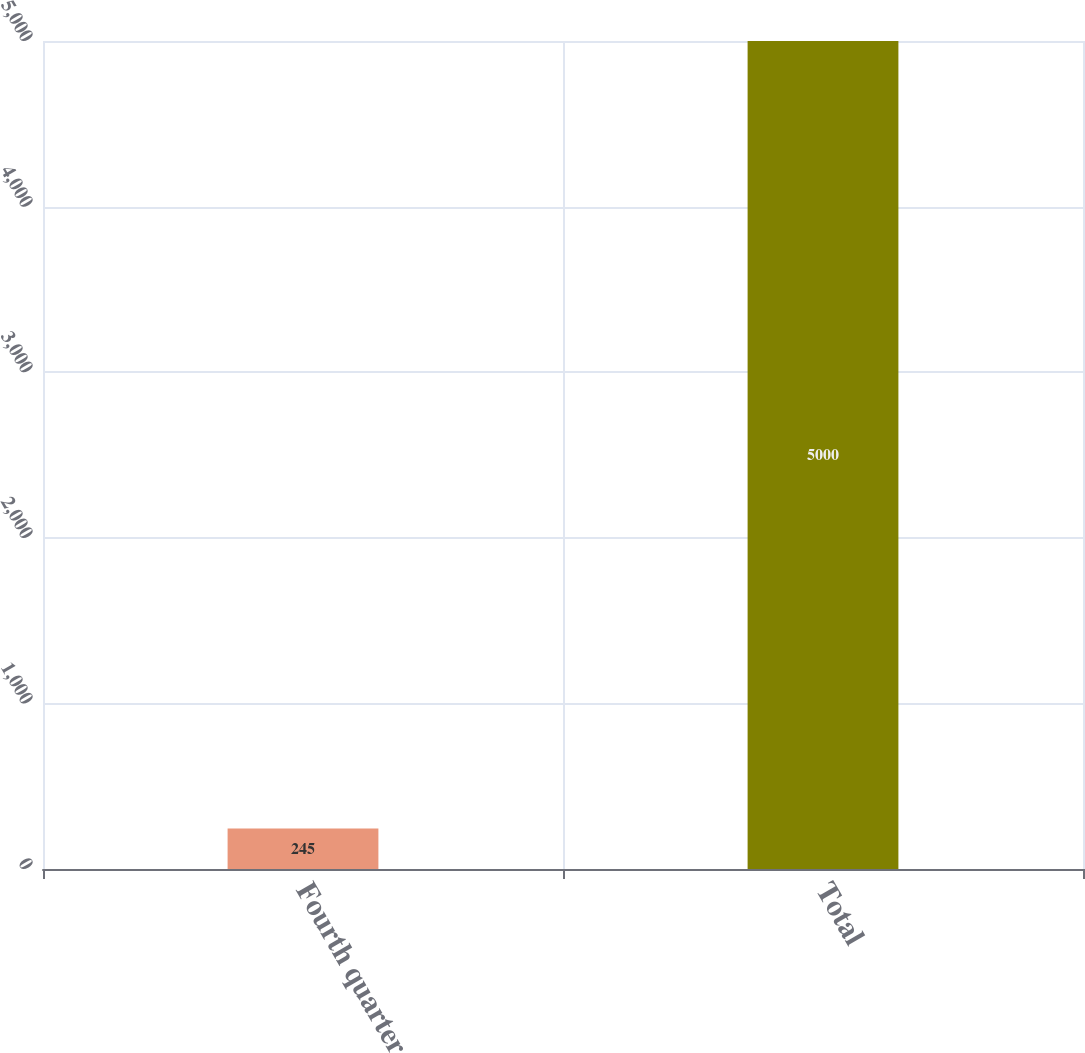<chart> <loc_0><loc_0><loc_500><loc_500><bar_chart><fcel>Fourth quarter<fcel>Total<nl><fcel>245<fcel>5000<nl></chart> 